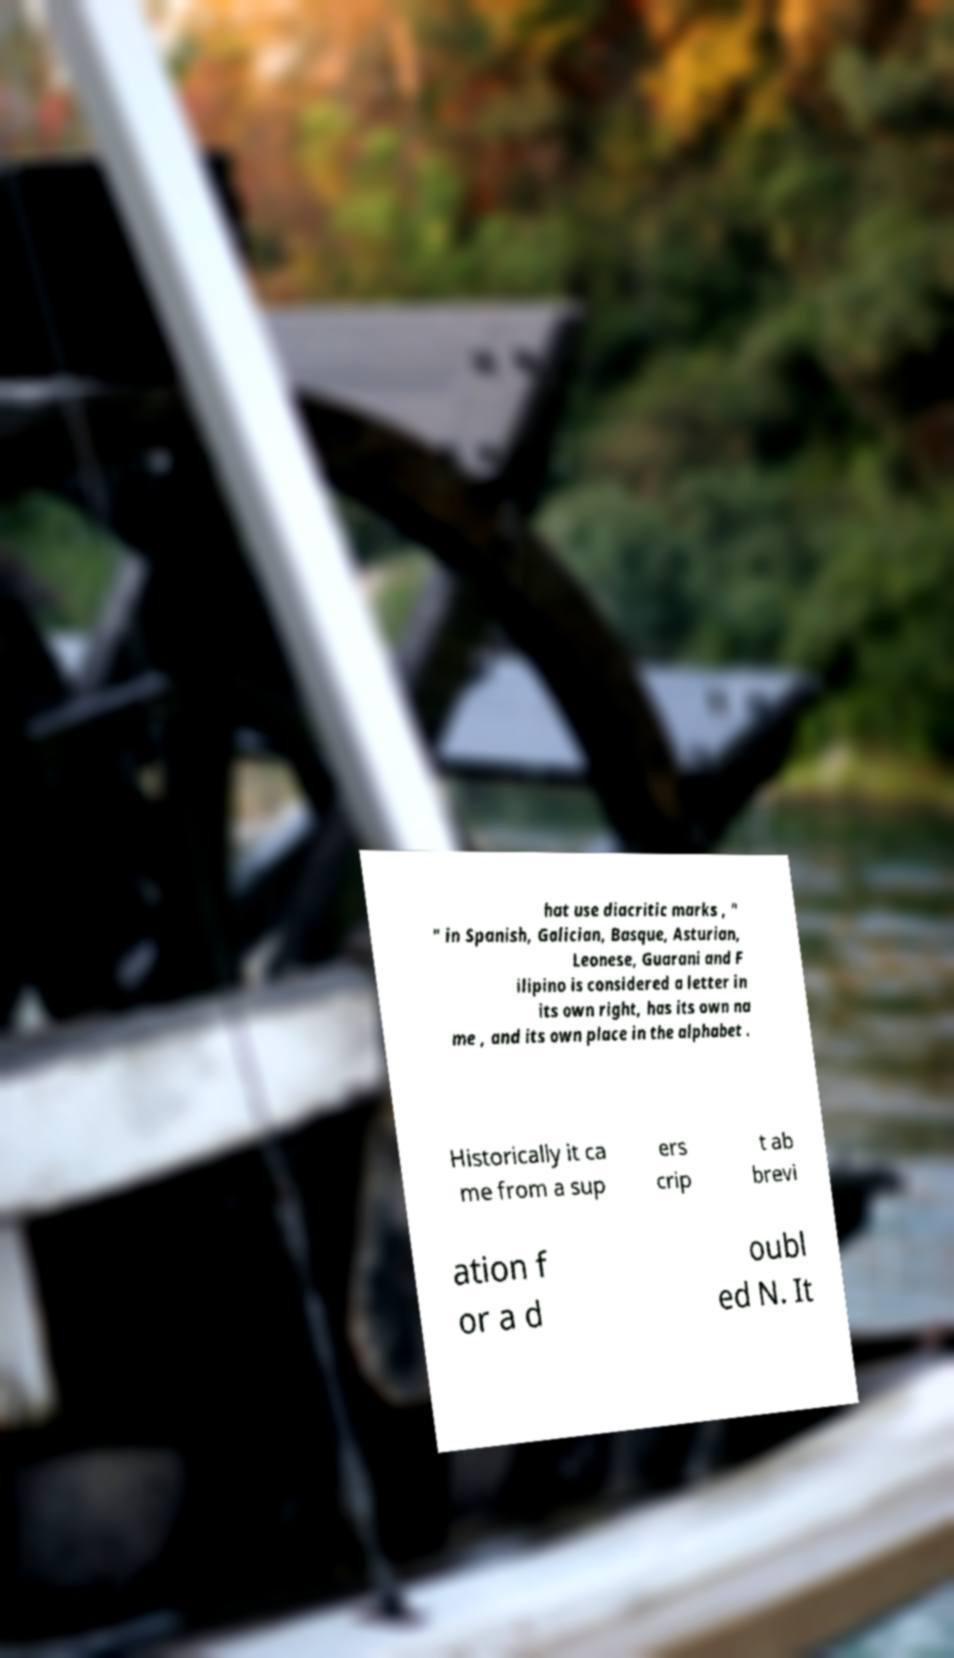Could you extract and type out the text from this image? hat use diacritic marks , " " in Spanish, Galician, Basque, Asturian, Leonese, Guarani and F ilipino is considered a letter in its own right, has its own na me , and its own place in the alphabet . Historically it ca me from a sup ers crip t ab brevi ation f or a d oubl ed N. It 